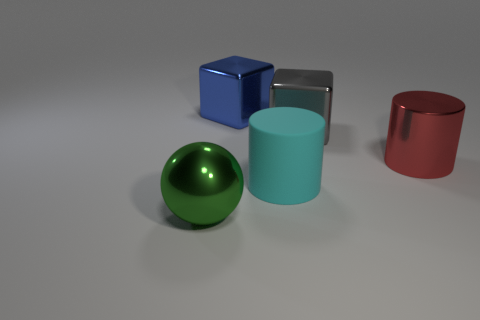Does the gray object have the same shape as the big blue object?
Provide a short and direct response. Yes. The metallic cylinder has what color?
Offer a terse response. Red. The big cylinder that is left of the shiny cube on the right side of the blue shiny object is what color?
Keep it short and to the point. Cyan. Are there any large green objects made of the same material as the red cylinder?
Your answer should be compact. Yes. What is the material of the cyan object on the left side of the large block right of the blue cube?
Your answer should be compact. Rubber. How many other large metal things have the same shape as the gray metallic thing?
Your response must be concise. 1. What is the shape of the big matte thing?
Your answer should be very brief. Cylinder. Is the number of big green blocks less than the number of large balls?
Your response must be concise. Yes. There is a large cyan thing that is the same shape as the red metallic thing; what is it made of?
Provide a succinct answer. Rubber. Are there more rubber cylinders than tiny purple rubber things?
Make the answer very short. Yes. 